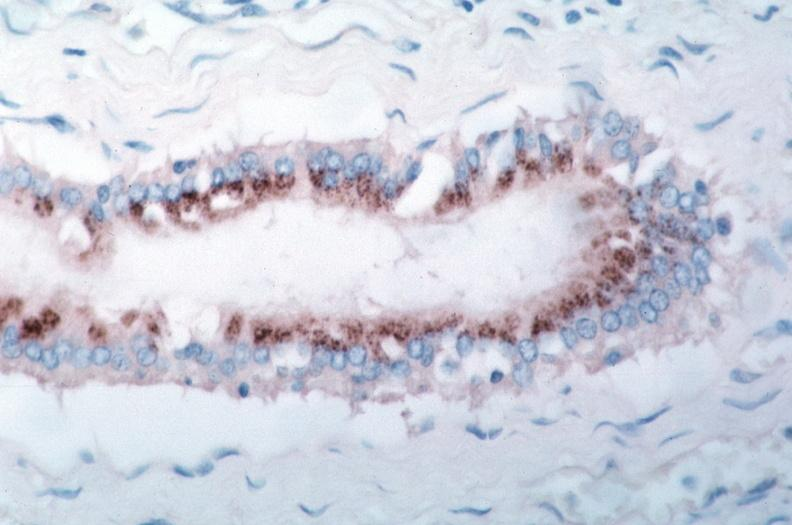does papillary intraductal adenocarcinoma show vasculitis?
Answer the question using a single word or phrase. No 